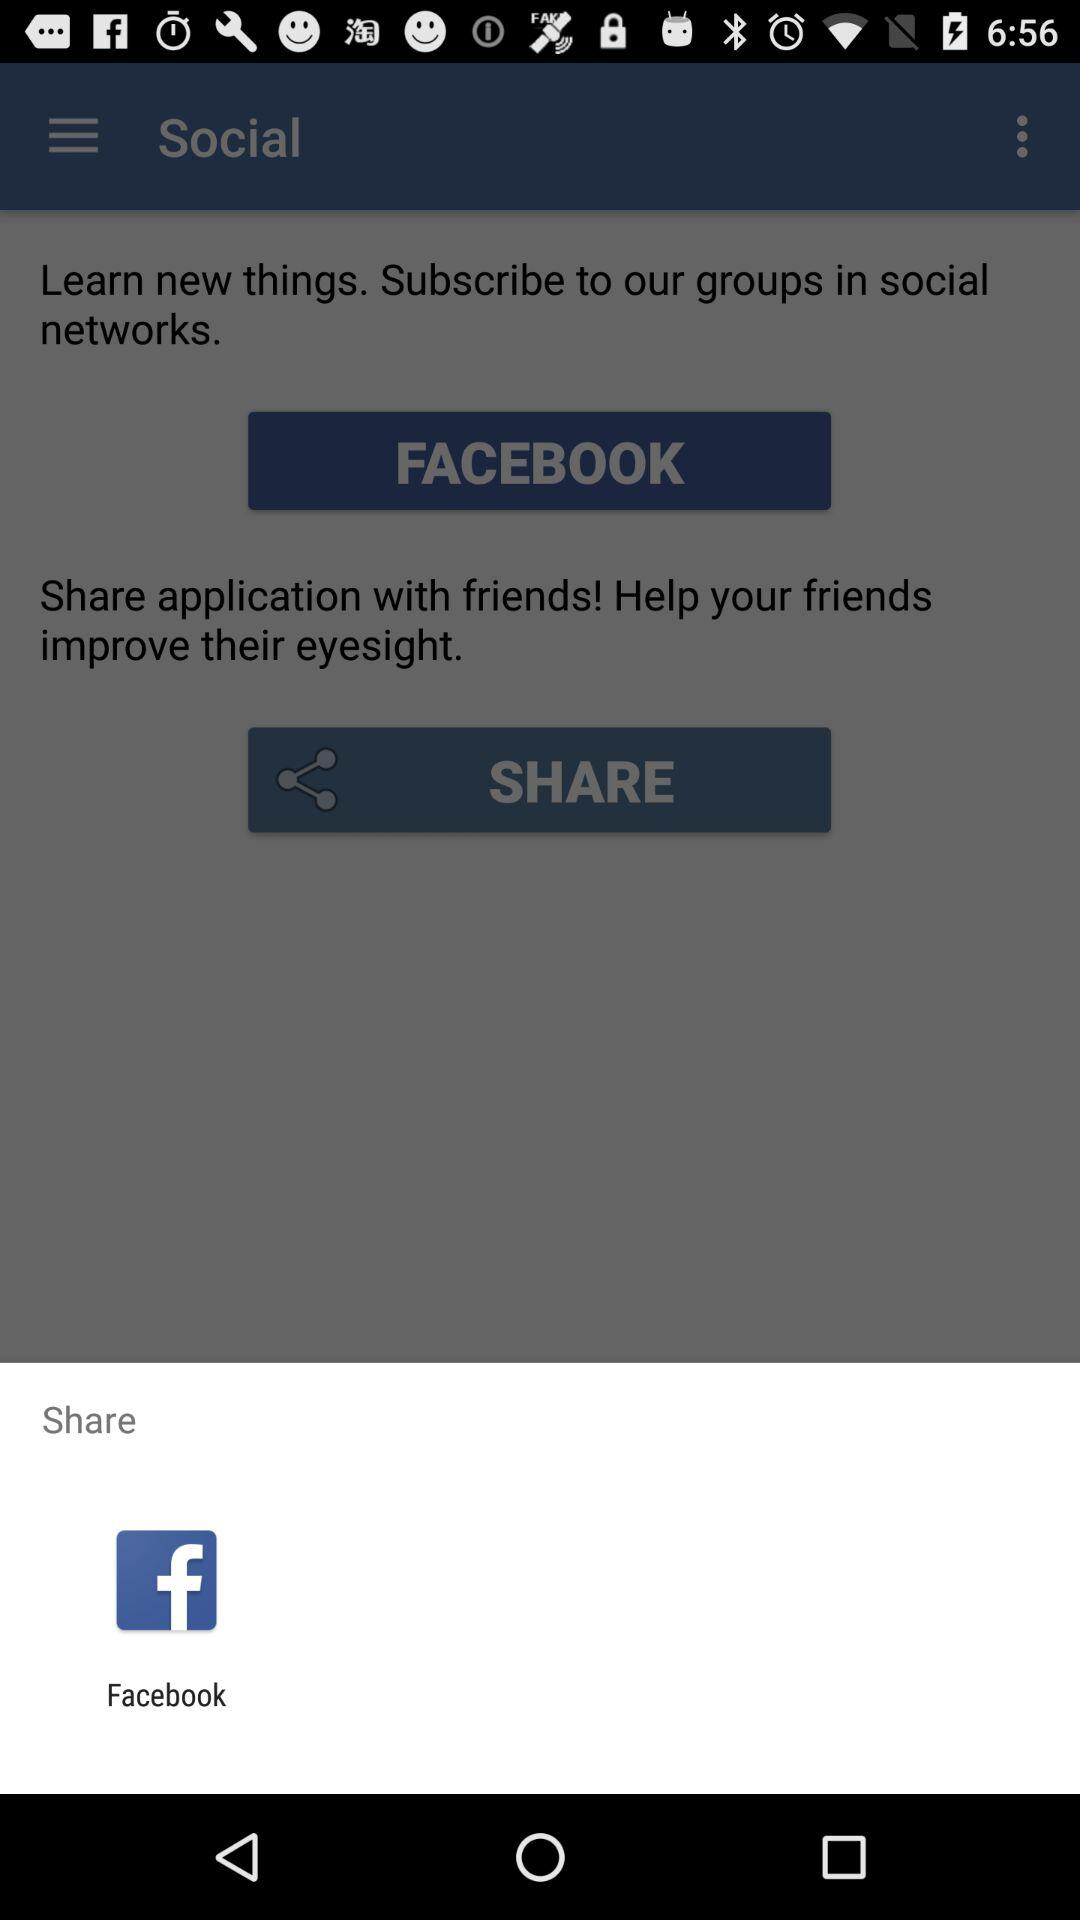What is the option to share? The option to share is "Facebook". 